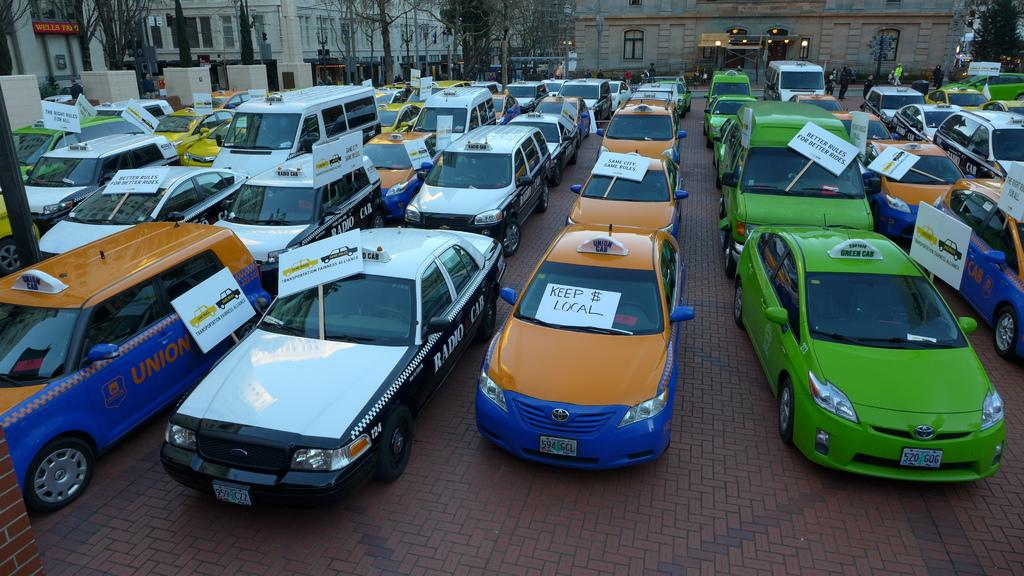<image>
Offer a succinct explanation of the picture presented. Multiple taxi cabs are parked in rows, all with signs on them, picketing for better cab fares. 